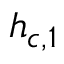Convert formula to latex. <formula><loc_0><loc_0><loc_500><loc_500>h _ { c , 1 }</formula> 